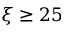Convert formula to latex. <formula><loc_0><loc_0><loc_500><loc_500>\xi \geq 2 5</formula> 